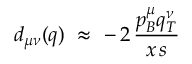Convert formula to latex. <formula><loc_0><loc_0><loc_500><loc_500>d _ { \mu \nu } ( q ) \, \approx \, - \, 2 \, \frac { p _ { B } ^ { \mu } q _ { T } ^ { \nu } } { x \, s }</formula> 